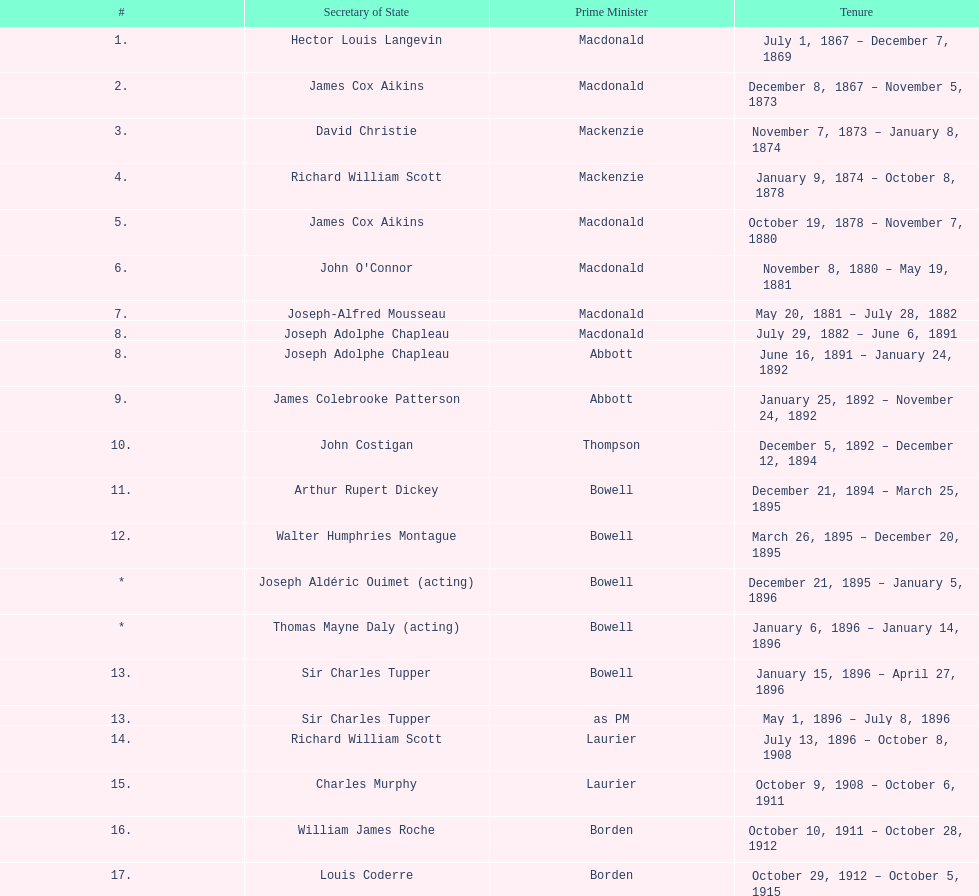Who held the position of secretary of state following jack pickersgill? Roch Pinard. Write the full table. {'header': ['#', 'Secretary of State', 'Prime Minister', 'Tenure'], 'rows': [['1.', 'Hector Louis Langevin', 'Macdonald', 'July 1, 1867 – December 7, 1869'], ['2.', 'James Cox Aikins', 'Macdonald', 'December 8, 1867 – November 5, 1873'], ['3.', 'David Christie', 'Mackenzie', 'November 7, 1873 – January 8, 1874'], ['4.', 'Richard William Scott', 'Mackenzie', 'January 9, 1874 – October 8, 1878'], ['5.', 'James Cox Aikins', 'Macdonald', 'October 19, 1878 – November 7, 1880'], ['6.', "John O'Connor", 'Macdonald', 'November 8, 1880 – May 19, 1881'], ['7.', 'Joseph-Alfred Mousseau', 'Macdonald', 'May 20, 1881 – July 28, 1882'], ['8.', 'Joseph Adolphe Chapleau', 'Macdonald', 'July 29, 1882 – June 6, 1891'], ['8.', 'Joseph Adolphe Chapleau', 'Abbott', 'June 16, 1891 – January 24, 1892'], ['9.', 'James Colebrooke Patterson', 'Abbott', 'January 25, 1892 – November 24, 1892'], ['10.', 'John Costigan', 'Thompson', 'December 5, 1892 – December 12, 1894'], ['11.', 'Arthur Rupert Dickey', 'Bowell', 'December 21, 1894 – March 25, 1895'], ['12.', 'Walter Humphries Montague', 'Bowell', 'March 26, 1895 – December 20, 1895'], ['*', 'Joseph Aldéric Ouimet (acting)', 'Bowell', 'December 21, 1895 – January 5, 1896'], ['*', 'Thomas Mayne Daly (acting)', 'Bowell', 'January 6, 1896 – January 14, 1896'], ['13.', 'Sir Charles Tupper', 'Bowell', 'January 15, 1896 – April 27, 1896'], ['13.', 'Sir Charles Tupper', 'as PM', 'May 1, 1896 – July 8, 1896'], ['14.', 'Richard William Scott', 'Laurier', 'July 13, 1896 – October 8, 1908'], ['15.', 'Charles Murphy', 'Laurier', 'October 9, 1908 – October 6, 1911'], ['16.', 'William James Roche', 'Borden', 'October 10, 1911 – October 28, 1912'], ['17.', 'Louis Coderre', 'Borden', 'October 29, 1912 – October 5, 1915'], ['18.', 'Pierre Édouard Blondin', 'Borden', 'October 6, 1915 – January 7, 1917'], ['19.', 'Esioff Léon Patenaude', 'Borden', 'January 8, 1917 – June 12, 1917'], ['*', 'Albert Sévigny (acting)', 'Borden', 'June 13, 1917 – August 24, 1917'], ['20.', 'Arthur Meighen', 'Borden', 'August 25, 1917 – October 12, 1917'], ['21.', 'Martin Burrell', 'Borden', 'October 12, 1917 – December 30, 1919'], ['22.', 'Arthur Lewis Sifton', 'Borden', 'December 31, 1919 – July 10, 1920'], ['22.', 'Arthur Lewis Sifton', 'Meighen', 'July 10, 1920 – January 21, 1921'], ['23.', 'Sir Henry Lumley Drayton', 'Meighen', 'January 24, 1921 – September 20, 1921'], ['24.', 'Rodolphe Monty', 'Meighen', 'September 21, 1921 – December 29, 1921'], ['25.', 'Arthur Bliss Copp', 'King', 'December 29, 1921 – September 24, 1921'], ['26.', 'Walter Edward Foster', 'King', 'September 26, 1925 – November 12, 1925'], ['*', 'Charles Murphy (acting)', 'King', 'November 13, 1925 – March 23, 1926'], ['*', 'Ernest Lapointe (acting)', 'King', 'March 24, 1926 – June 28, 1926'], ['27.', 'Guillaume André Fauteux', 'Meighen', 'August 23, 1926 – September 25, 1926'], ['28.', 'Fernand Rinfret', 'King', 'September 25, 1926 – August 7, 1930'], ['29.', 'Charles Hazlitt Cahan', 'Bennett', 'August 7, 1930 – October 23, 1935'], ['', 'Fernand Rinfret (second time)', 'King', 'October 23, 1935 – July 12, 1939'], ['*', 'Ernest Lapointe (acting – 2nd time)', 'King', 'July 26, 1939 – May 8, 1940'], ['30.', 'Pierre-François Casgrain', 'King', 'May 9, 1940 – December 14, 1941'], ['31.', 'Norman Alexander McLarty', 'King', 'December 15, 1941 – April 17, 1945'], ['32.', 'Paul Joseph James Martin', 'King', 'April 18, 1945 – December 11, 1946'], ['33.', 'Colin William George Gibson', 'King', 'December 12, 1946 – November 15, 1948'], ['33.', 'Colin William George Gibson', 'St. Laurent', 'November 15, 1948 – March 31, 1949'], ['34.', 'Frederick Gordon Bradley', 'St. Laurent', 'March 31, 1949 – June 11, 1953'], ['35.', 'Jack Pickersgill', 'St. Laurent', 'June 11, 1953 – June 30, 1954'], ['36.', 'Roch Pinard', 'St. Laurent', 'July 1, 1954 – June 21, 1957'], ['37.', 'Ellen Louks Fairclough', 'Diefenbaker', 'June 21, 1957 – May 11, 1958'], ['38.', 'Henri Courtemanche', 'Diefenbaker', 'May 12, 1958 – June 19, 1960'], ['*', 'Léon Balcer (acting minister)', 'Diefenbaker', 'June 21, 1960 – October 10, 1960'], ['39.', 'Noël Dorion', 'Diefenbaker', 'October 11, 1960 – July 5, 1962'], ['*', 'Léon Balcer (acting minister – 2nd time)', 'Diefenbaker', 'July 11, 1962 – August 8, 1962'], ['40.', 'George Ernest Halpenny', 'Diefenbaker', 'August 9, 1962 – April 22, 1963'], ['', 'Jack Pickersgill (second time)', 'Pearson', 'April 22, 1963 – February 2, 1964'], ['41.', 'Maurice Lamontagne', 'Pearson', 'February 2, 1964 – December 17, 1965'], ['42.', 'Judy LaMarsh', 'Pearson', 'December 17, 1965 – April 9, 1968'], ['*', 'John Joseph Connolly (acting minister)', 'Pearson', 'April 10, 1968 – April 20, 1968'], ['43.', 'Jean Marchand', 'Trudeau', 'April 20, 1968 – July 5, 1968'], ['44.', 'Gérard Pelletier', 'Trudeau', 'July 5, 1968 – November 26, 1972'], ['45.', 'James Hugh Faulkner', 'Trudeau', 'November 27, 1972 – September 13, 1976'], ['46.', 'John Roberts', 'Trudeau', 'September 14, 1976 – June 3, 1979'], ['47.', 'David MacDonald', 'Clark', 'June 4, 1979 – March 2, 1980'], ['48.', 'Francis Fox', 'Trudeau', 'March 3, 1980 – September 21, 1981'], ['49.', 'Gerald Regan', 'Trudeau', 'September 22, 1981 – October 5, 1982'], ['50.', 'Serge Joyal', 'Trudeau', 'October 6, 1982 – June 29, 1984'], ['50.', 'Serge Joyal', 'Turner', 'June 30, 1984 – September 16, 1984'], ['51.', 'Walter McLean', 'Mulroney', 'September 17, 1984 – April 19, 1985'], ['52.', 'Benoit Bouchard', 'Mulroney', 'April 20, 1985 – June 29, 1986'], ['53.', 'David Crombie', 'Mulroney', 'June 30, 1986 – March 30, 1988'], ['54.', 'Lucien Bouchard', 'Mulroney', 'March 31, 1988 – January 29, 1989'], ['55.', 'Gerry Weiner', 'Mulroney', 'January 30, 1989 – April 20, 1991'], ['56.', 'Robert de Cotret', 'Mulroney', 'April 21, 1991 – January 3, 1993'], ['57.', 'Monique Landry', 'Mulroney', 'January 4, 1993 – June 24, 1993'], ['57.', 'Monique Landry', 'Campbell', 'June 24, 1993 – November 3, 1993'], ['58.', 'Sergio Marchi', 'Chrétien', 'November 4, 1993 – January 24, 1996'], ['59.', 'Lucienne Robillard', 'Chrétien', 'January 25, 1996 – July 12, 1996']]} 